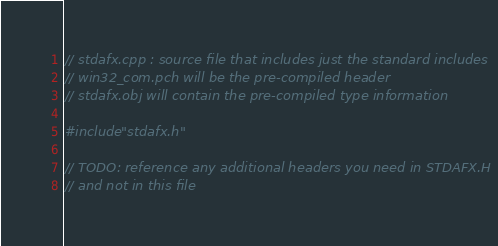Convert code to text. <code><loc_0><loc_0><loc_500><loc_500><_C++_>// stdafx.cpp : source file that includes just the standard includes
// win32_com.pch will be the pre-compiled header
// stdafx.obj will contain the pre-compiled type information

#include "stdafx.h"

// TODO: reference any additional headers you need in STDAFX.H
// and not in this file
</code> 